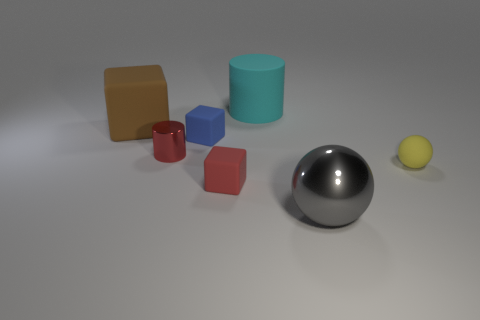The cylinder that is in front of the tiny blue rubber object is what color?
Give a very brief answer. Red. How many other things are there of the same color as the big cylinder?
Your answer should be compact. 0. Does the block left of the red cylinder have the same size as the small yellow rubber sphere?
Give a very brief answer. No. There is a small red metal thing; how many large things are in front of it?
Offer a terse response. 1. Is there a red rubber cylinder of the same size as the metal ball?
Offer a terse response. No. Do the rubber cylinder and the large block have the same color?
Give a very brief answer. No. What is the color of the metal thing to the left of the tiny block that is in front of the small blue object?
Provide a short and direct response. Red. What number of matte objects are both right of the red cylinder and left of the metallic sphere?
Offer a terse response. 3. How many small gray metallic objects have the same shape as the small yellow thing?
Offer a terse response. 0. Are the gray sphere and the small cylinder made of the same material?
Your answer should be very brief. Yes. 